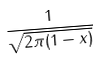<formula> <loc_0><loc_0><loc_500><loc_500>\frac { 1 } { \sqrt { 2 \pi ( 1 - x ) } }</formula> 